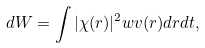<formula> <loc_0><loc_0><loc_500><loc_500>d W = \int | \chi ( r ) | ^ { 2 } w v ( r ) d r d t ,</formula> 